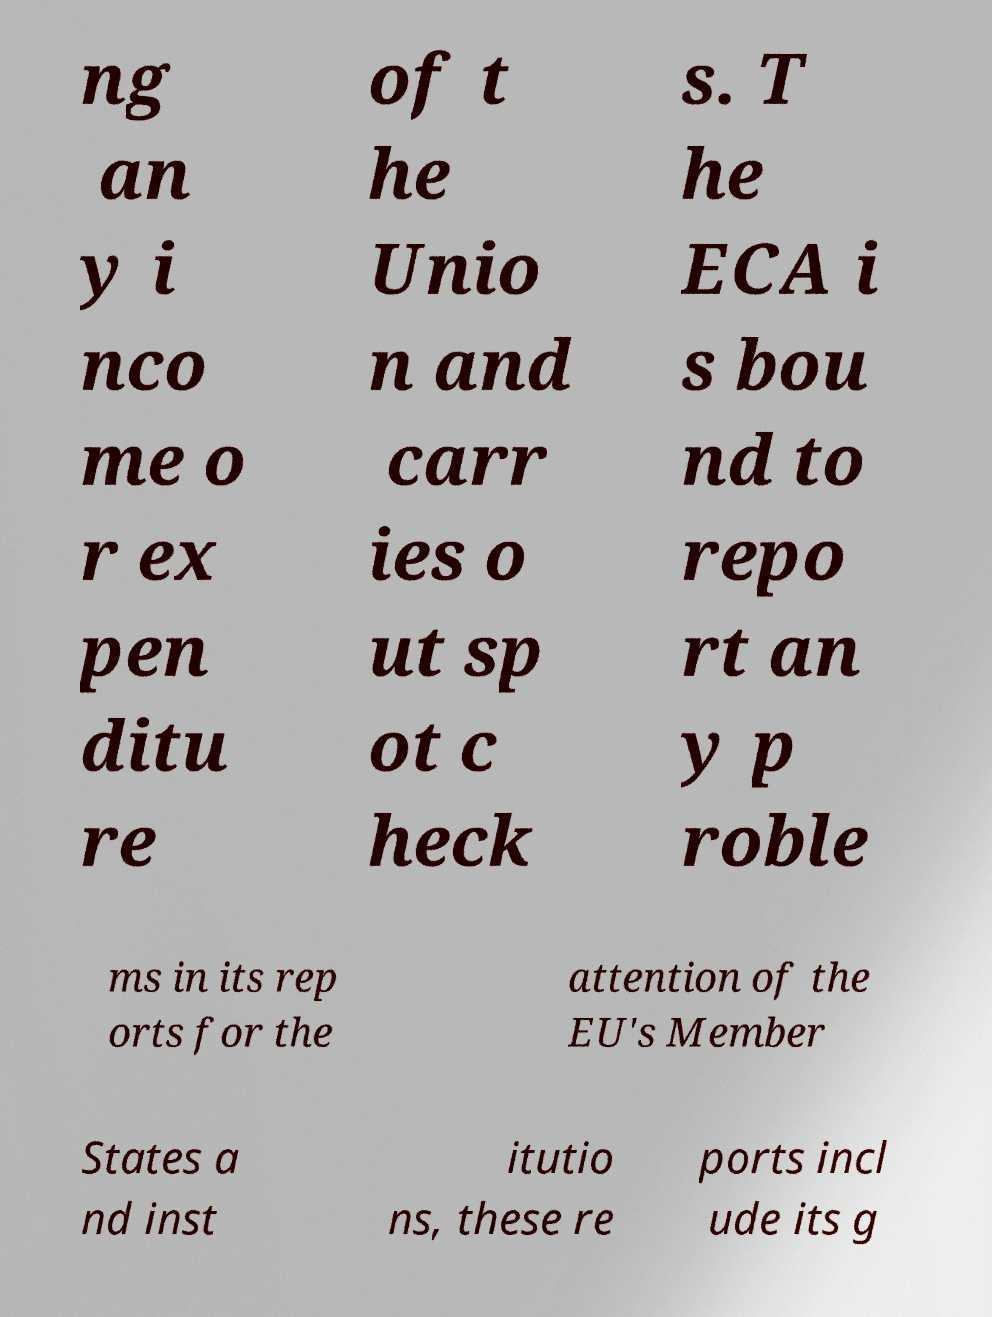Can you read and provide the text displayed in the image?This photo seems to have some interesting text. Can you extract and type it out for me? ng an y i nco me o r ex pen ditu re of t he Unio n and carr ies o ut sp ot c heck s. T he ECA i s bou nd to repo rt an y p roble ms in its rep orts for the attention of the EU's Member States a nd inst itutio ns, these re ports incl ude its g 